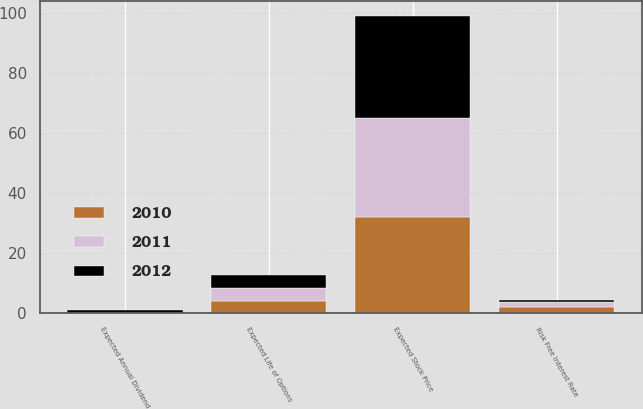Convert chart. <chart><loc_0><loc_0><loc_500><loc_500><stacked_bar_chart><ecel><fcel>Expected Stock Price<fcel>Risk Free Interest Rate<fcel>Expected Life of Options<fcel>Expected Annual Dividend<nl><fcel>2012<fcel>34<fcel>0.8<fcel>4.5<fcel>0.9<nl><fcel>2011<fcel>33<fcel>1.7<fcel>4.1<fcel>0<nl><fcel>2010<fcel>32<fcel>2<fcel>4.1<fcel>0<nl></chart> 